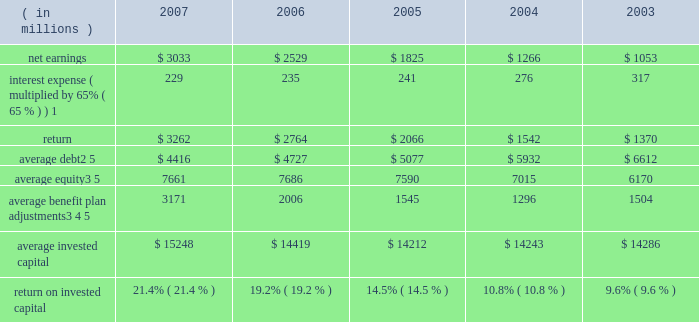( c ) includes the effects of items not considered in the assessment of the operating performance of our business segments which increased operating profit by $ 230 million , $ 150 million after tax ( $ 0.34 per share ) .
Also includes expenses of $ 16 million , $ 11 million after tax ( $ 0.03 per share ) for a debt exchange , and a reduction in income tax expense of $ 62 million ( $ 0.14 per share ) resulting from a tax benefit related to claims we filed for additional extraterritorial income exclusion ( eti ) tax benefits .
On a combined basis , these items increased earnings by $ 201 million after tax ( $ 0.45 per share ) .
( d ) includes the effects of items not considered in the assessment of the operating performance of our business segments which , on a combined basis , increased operating profit by $ 173 million , $ 113 million after tax ( $ 0.25 per share ) .
( e ) includes the effects of items not considered in the assessment of the operating performance of our business segments which decreased operating profit by $ 61 million , $ 54 million after tax ( $ 0.12 per share ) .
Also includes a charge of $ 154 million , $ 100 million after tax ( $ 0.22 per share ) for the early repayment of debt , and a reduction in income tax expense resulting from the closure of an internal revenue service examination of $ 144 million ( $ 0.32 per share ) .
On a combined basis , these items reduced earnings by $ 10 million after tax ( $ 0.02 per share ) .
( f ) includes the effects of items not considered in the assessment of the operating performance of our business segments which , on a combined basis , decreased operating profit by $ 7 million , $ 6 million after tax ( $ 0.01 per share ) .
Also includes a charge of $ 146 million , $ 96 million after tax ( $ 0.21 per share ) for the early repayment of debt .
( g ) we define return on invested capital ( roic ) as net earnings plus after-tax interest expense divided by average invested capital ( stockholders 2019 equity plus debt ) , after adjusting stockholders 2019 equity by adding back adjustments related to postretirement benefit plans .
We believe that reporting roic provides investors with greater visibility into how effectively we use the capital invested in our operations .
We use roic to evaluate multi-year investment decisions and as a long-term performance measure , and also use it as a factor in evaluating management performance under certain of our incentive compensation plans .
Roic is not a measure of financial performance under generally accepted accounting principles , and may not be defined and calculated by other companies in the same manner .
Roic should not be considered in isolation or as an alternative to net earnings as an indicator of performance .
We calculate roic as follows : ( in millions ) 2007 2006 2005 2004 2003 .
1 represents after-tax interest expense utilizing the federal statutory rate of 35% ( 35 % ) .
2 debt consists of long-term debt , including current maturities of long-term debt , and short-term borrowings ( if any ) .
3 equity includes non-cash adjustments , primarily for unrecognized benefit plan actuarial losses and prior service costs in 2007 and 2006 , the adjustment for the adoption of fas 158 in 2006 , and the additional minimum pension liability in years prior to 2007 .
4 average benefit plan adjustments reflect the cumulative value of entries identified in our statement of stockholders equity under the captions 201cpostretirement benefit plans , 201d 201cadjustment for adoption of fas 158 201d and 201cminimum pension liability . 201d the total of annual benefit plan adjustments to equity were : 2007 = $ 1706 million ; 2006 = ( $ 1883 ) million ; 2005 = ( $ 105 ) million ; 2004 = ( $ 285 ) million ; 2003 = $ 331 million ; 2002 = ( $ 1537 million ) ; and 2001 = ( $ 33 million ) .
As these entries are recorded in the fourth quarter , the value added back to our average equity in a given year is the cumulative impact of all prior year entries plus 20% ( 20 % ) of the current year entry value .
5 yearly averages are calculated using balances at the start of the year and at the end of each quarter. .
What was the difference in return on invested capital from 2006 to 2007? 
Computations: (21.4% - 19.2%)
Answer: 0.022. 